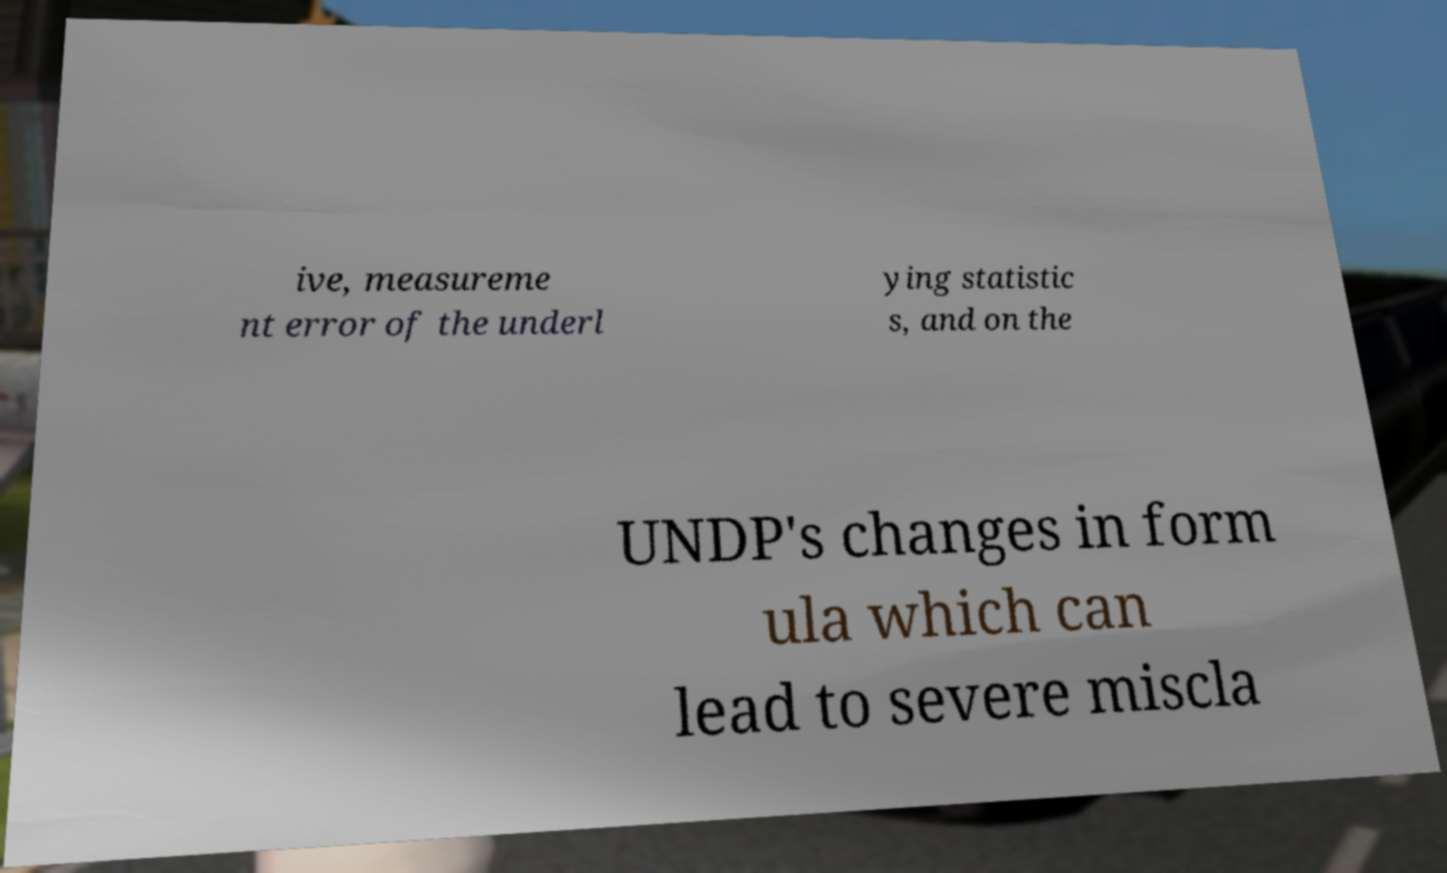For documentation purposes, I need the text within this image transcribed. Could you provide that? ive, measureme nt error of the underl ying statistic s, and on the UNDP's changes in form ula which can lead to severe miscla 